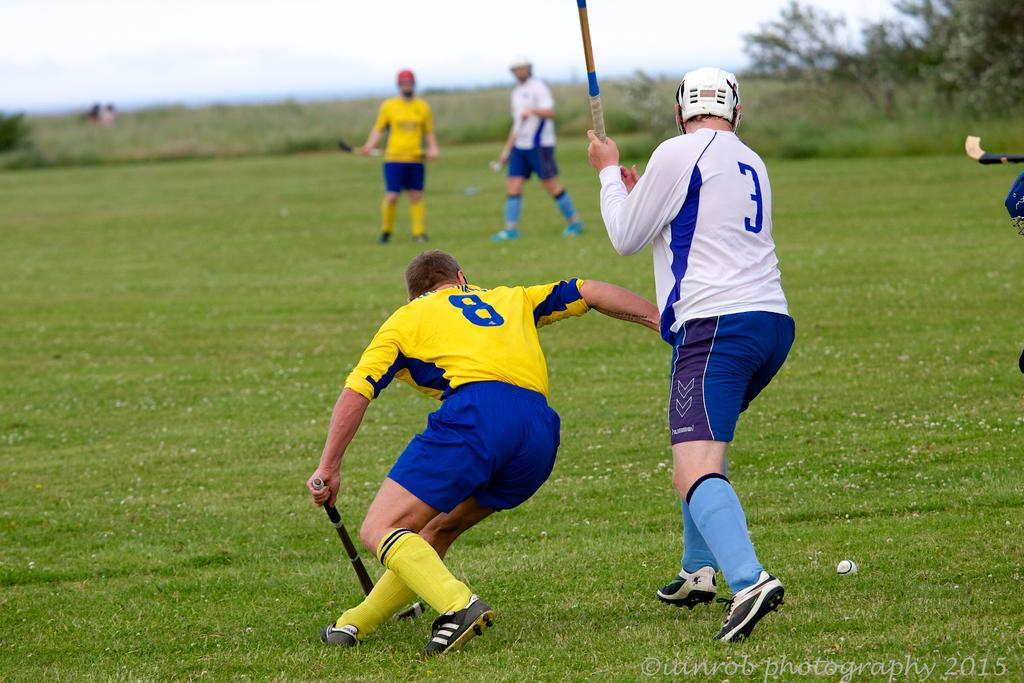<image>
Render a clear and concise summary of the photo. Team member number 3 stands with his stick up as opposing team member number 8 kneels with his stick down. 